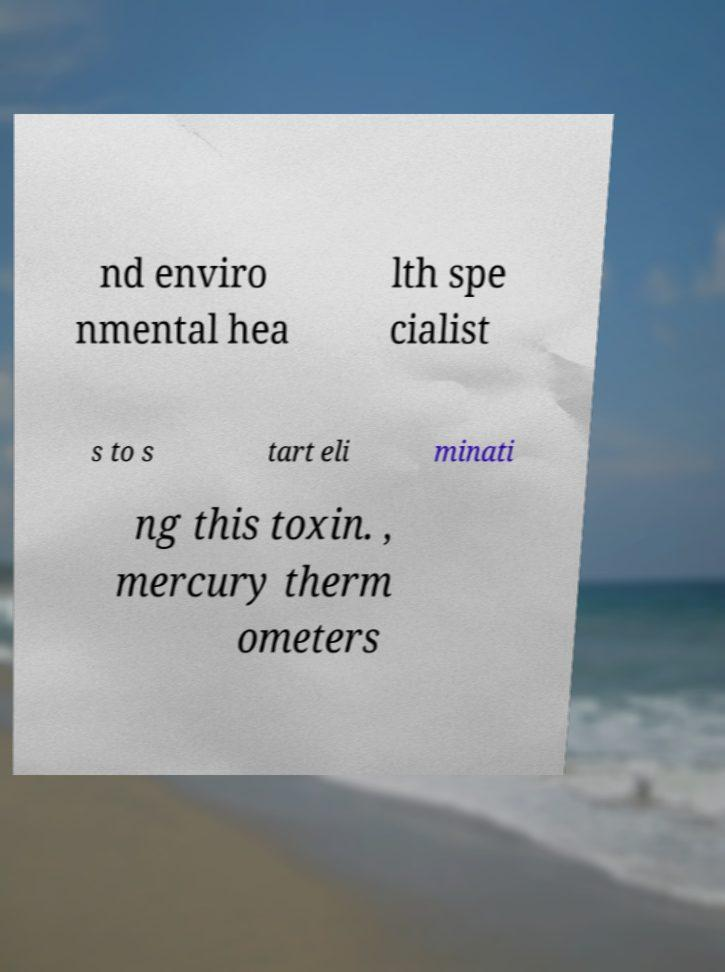For documentation purposes, I need the text within this image transcribed. Could you provide that? nd enviro nmental hea lth spe cialist s to s tart eli minati ng this toxin. , mercury therm ometers 